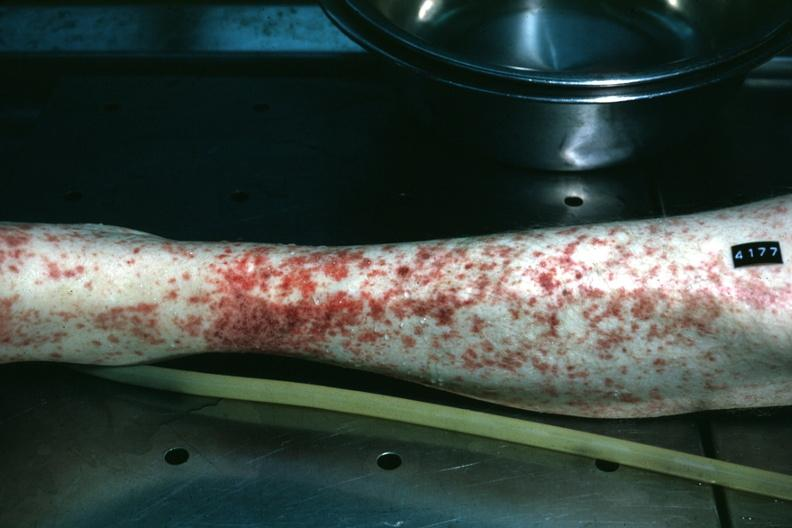does this image show leg excellent example of skin hemorrhages?
Answer the question using a single word or phrase. Yes 